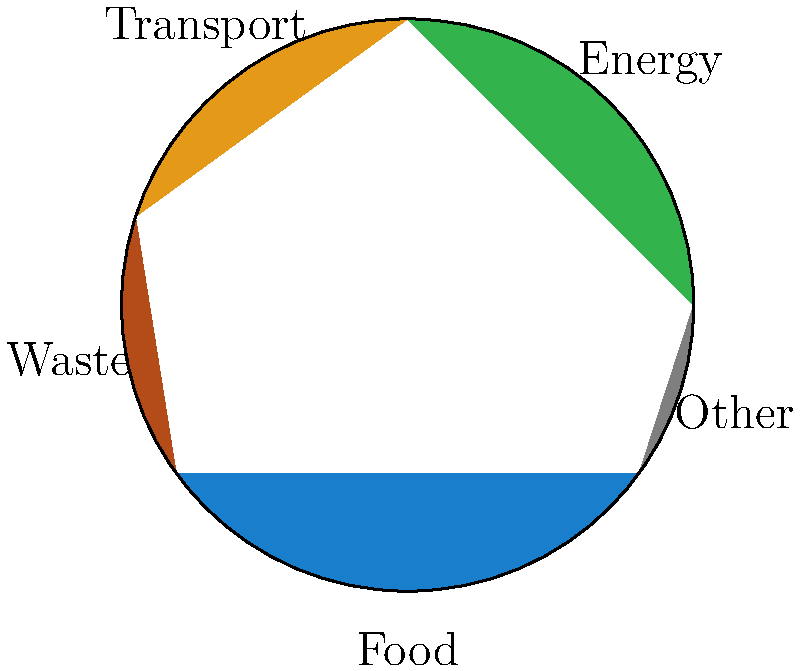As an environmental film distributor, you're analyzing the carbon footprint reduction achieved by a community after implementing measures promoted in your latest documentary. The pie chart shows the distribution of carbon emissions across different sectors before the initiatives. If the total emissions were reduced by 15%, and the waste sector saw a 40% reduction in its emissions, what percentage of the new total emissions does the waste sector now represent? Let's approach this step-by-step:

1) First, we need to identify the initial percentage of emissions from the waste sector:
   From the pie chart, we can see that waste accounts for 15% of the total emissions.

2) Let's assume the initial total emissions were 100 units for easy calculation.
   So, waste initially accounted for 15 units.

3) The total emissions were reduced by 15%. So the new total is:
   $100 - (15\% \times 100) = 100 - 15 = 85$ units

4) The waste sector saw a 40% reduction in its emissions. So the new waste emissions are:
   $15 - (40\% \times 15) = 15 - 6 = 9$ units

5) To find what percentage the waste sector now represents, we divide the new waste emissions by the new total emissions and multiply by 100:

   $\frac{9}{85} \times 100 = 10.59\%$

Therefore, after the reduction initiatives, the waste sector now represents approximately 10.59% of the new total emissions.
Answer: 10.59% 